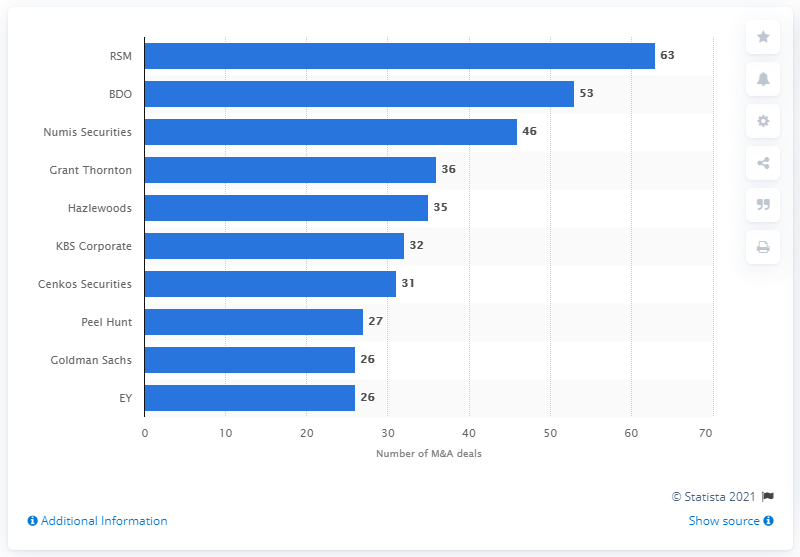Identify some key points in this picture. RSM advised on 63 deals in 2020. The deal volume of Numis Securities was 46.. In 2020, RSM was the leading financial advisor for merger and acquisition transactions in Greater London. BDO's deal volume in 2020 was 53. 